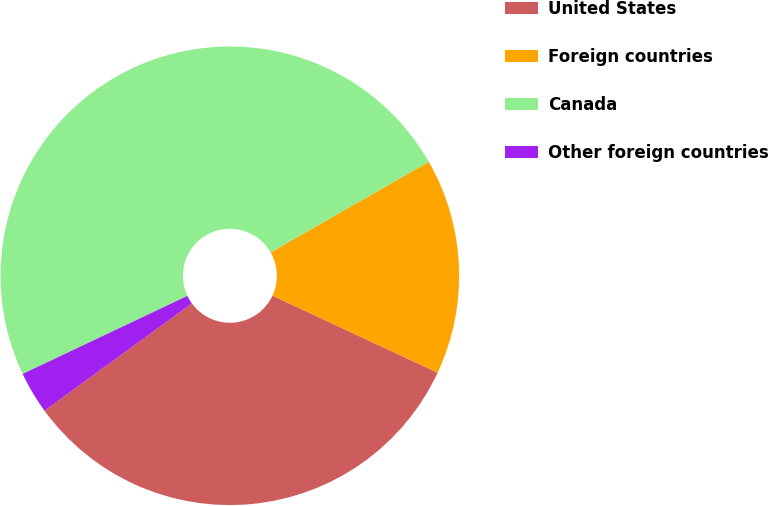<chart> <loc_0><loc_0><loc_500><loc_500><pie_chart><fcel>United States<fcel>Foreign countries<fcel>Canada<fcel>Other foreign countries<nl><fcel>33.04%<fcel>15.23%<fcel>48.76%<fcel>2.97%<nl></chart> 